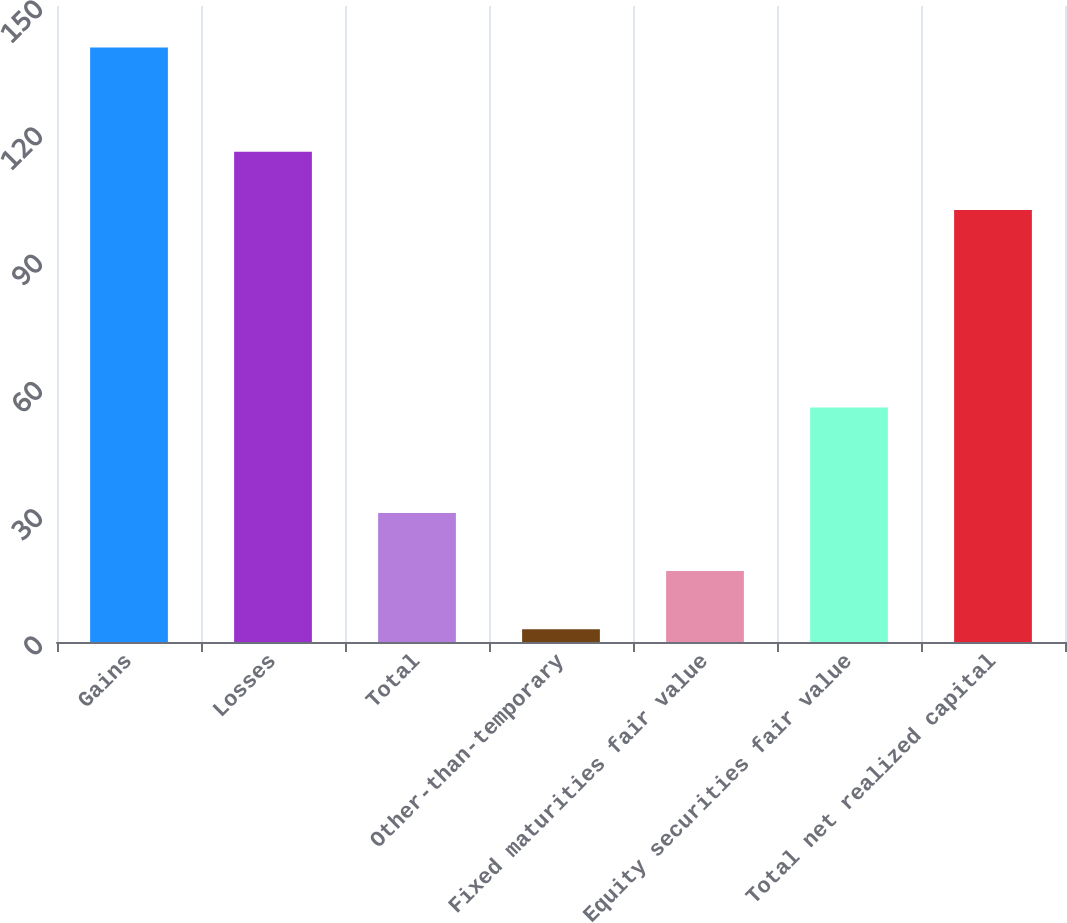Convert chart. <chart><loc_0><loc_0><loc_500><loc_500><bar_chart><fcel>Gains<fcel>Losses<fcel>Total<fcel>Other-than-temporary<fcel>Fixed maturities fair value<fcel>Equity securities fair value<fcel>Total net realized capital<nl><fcel>140.2<fcel>115.62<fcel>30.44<fcel>3<fcel>16.72<fcel>55.3<fcel>101.9<nl></chart> 